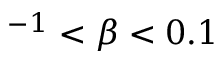<formula> <loc_0><loc_0><loc_500><loc_500>^ { - 1 } < \beta < 0 . 1</formula> 